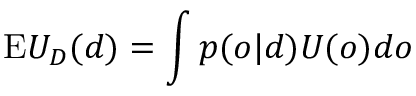Convert formula to latex. <formula><loc_0><loc_0><loc_500><loc_500>{ E } U _ { D } ( d ) = \int { p ( o | d ) U ( o ) d o }</formula> 